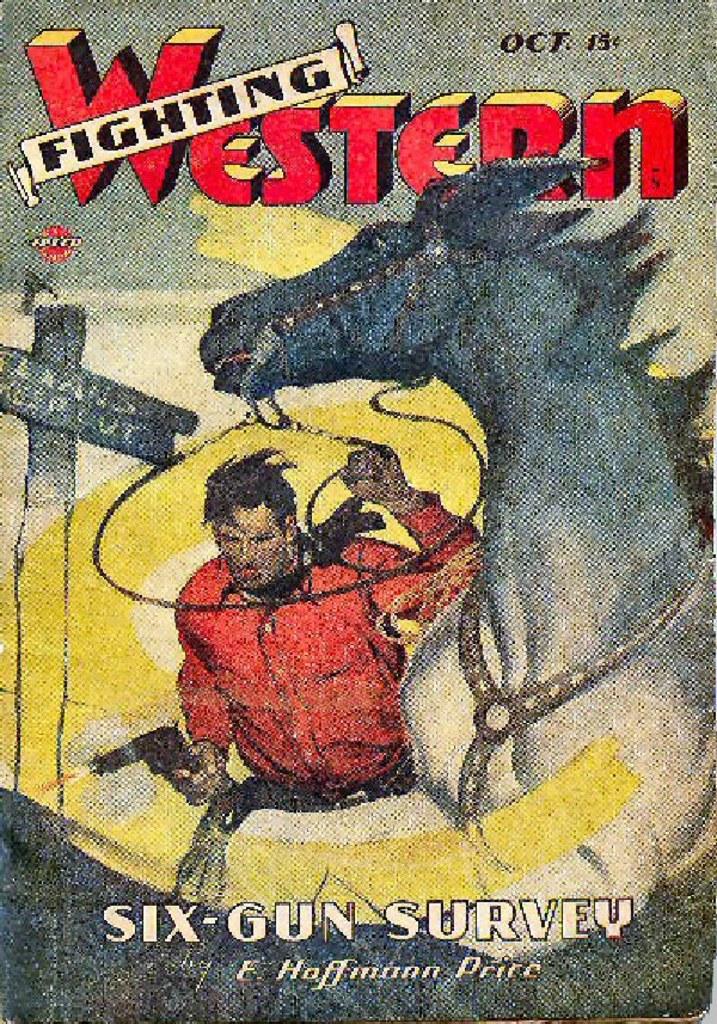How much was this magazine?
Provide a short and direct response. 15 cents. What is the month on this comic?
Provide a succinct answer. October. 